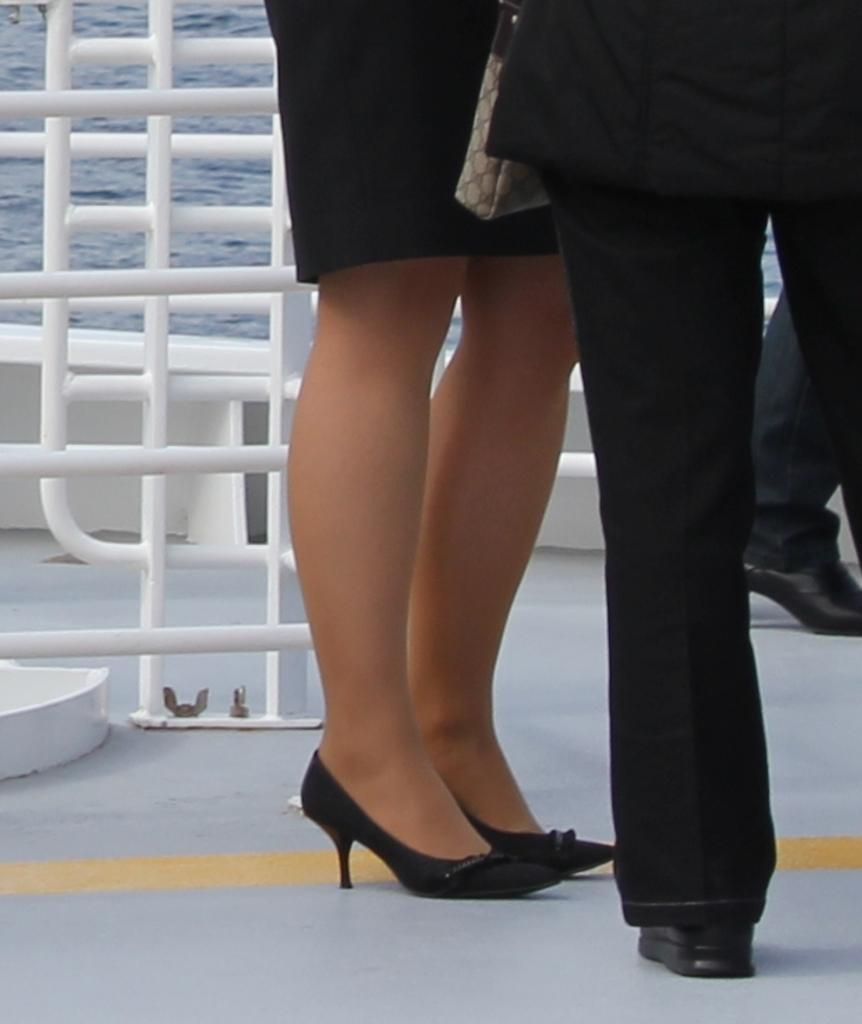What body parts of two individuals can be seen in the image? There are legs of a woman and a man in the image. What surface are the individuals standing on? Both individuals are standing on the floor. What can be seen in the background of the image? There are poles and water visible in the background of the image. What type of mailbox can be seen in the image? There is no mailbox present in the image. How does the love between the two individuals manifest in the image? The image does not depict any emotions or relationships between the individuals, so it is not possible to determine how love might manifest in the image. 